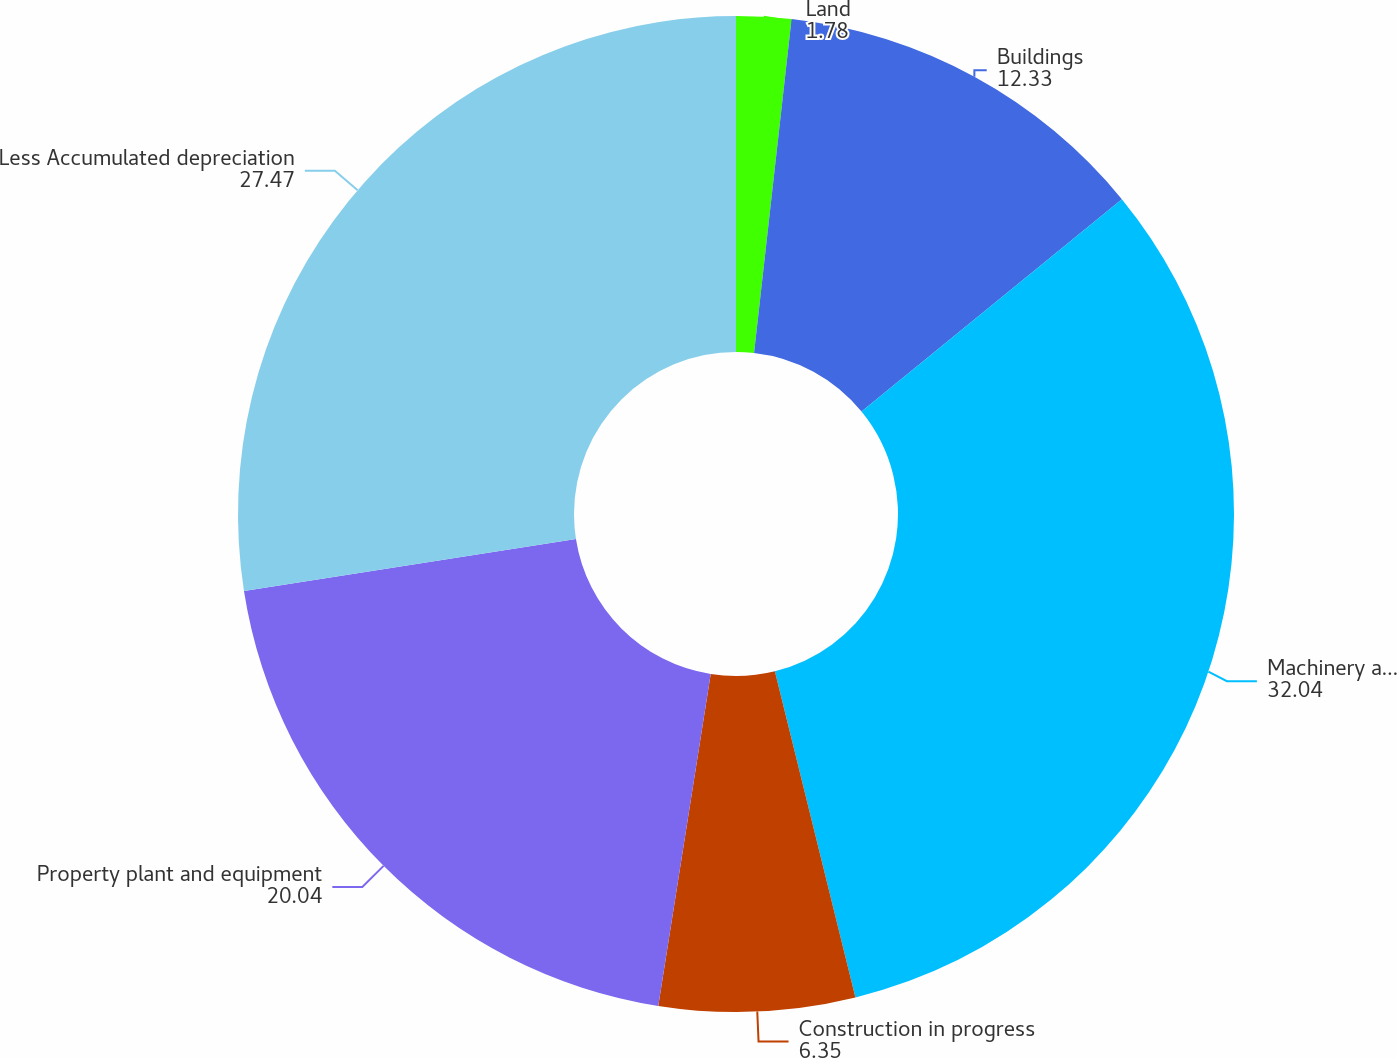Convert chart. <chart><loc_0><loc_0><loc_500><loc_500><pie_chart><fcel>Land<fcel>Buildings<fcel>Machinery and equipment<fcel>Construction in progress<fcel>Property plant and equipment<fcel>Less Accumulated depreciation<nl><fcel>1.78%<fcel>12.33%<fcel>32.04%<fcel>6.35%<fcel>20.04%<fcel>27.47%<nl></chart> 